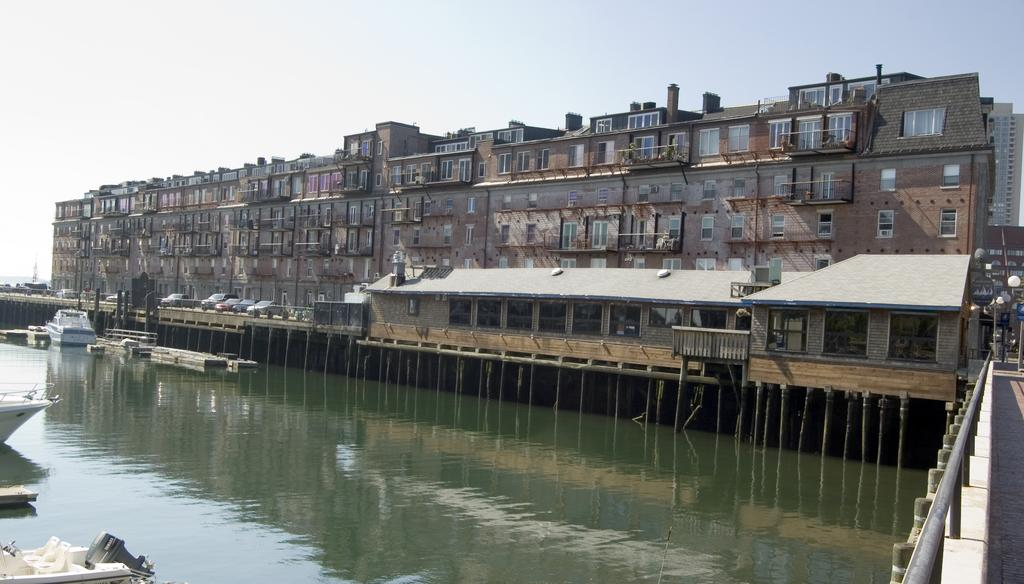What type of structures can be seen in the image? There are buildings in the image. What vehicles are parked in the image? Cars are parked in the image. What is floating in the water in the image? There are boats in the water in the image. What type of lighting is present in the image? Pole lights are visible in the image. What is the condition of the sky in the image? The sky is cloudy in the image. What is the average income of the laborers working on the team in the image? There is no information about laborers or a team in the image, so we cannot determine their average income. 